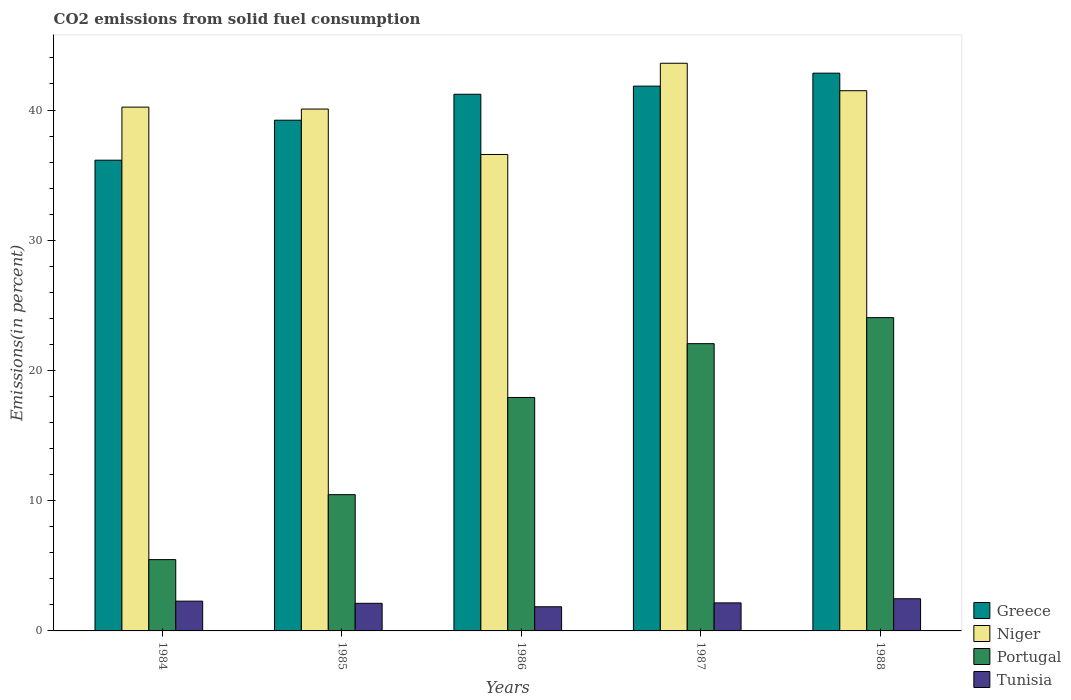Are the number of bars per tick equal to the number of legend labels?
Keep it short and to the point. Yes. Are the number of bars on each tick of the X-axis equal?
Offer a terse response. Yes. How many bars are there on the 5th tick from the left?
Provide a short and direct response. 4. How many bars are there on the 4th tick from the right?
Offer a terse response. 4. What is the total CO2 emitted in Greece in 1984?
Make the answer very short. 36.15. Across all years, what is the maximum total CO2 emitted in Greece?
Provide a succinct answer. 42.83. Across all years, what is the minimum total CO2 emitted in Portugal?
Ensure brevity in your answer.  5.48. In which year was the total CO2 emitted in Portugal maximum?
Keep it short and to the point. 1988. In which year was the total CO2 emitted in Tunisia minimum?
Provide a short and direct response. 1986. What is the total total CO2 emitted in Greece in the graph?
Offer a terse response. 201.24. What is the difference between the total CO2 emitted in Tunisia in 1984 and that in 1985?
Keep it short and to the point. 0.17. What is the difference between the total CO2 emitted in Portugal in 1988 and the total CO2 emitted in Niger in 1985?
Provide a succinct answer. -16.02. What is the average total CO2 emitted in Niger per year?
Offer a terse response. 40.39. In the year 1988, what is the difference between the total CO2 emitted in Tunisia and total CO2 emitted in Greece?
Your answer should be very brief. -40.36. In how many years, is the total CO2 emitted in Niger greater than 18 %?
Offer a terse response. 5. What is the ratio of the total CO2 emitted in Greece in 1985 to that in 1988?
Your response must be concise. 0.92. What is the difference between the highest and the second highest total CO2 emitted in Niger?
Offer a terse response. 2.11. What is the difference between the highest and the lowest total CO2 emitted in Greece?
Your answer should be very brief. 6.68. In how many years, is the total CO2 emitted in Niger greater than the average total CO2 emitted in Niger taken over all years?
Your response must be concise. 2. Is the sum of the total CO2 emitted in Niger in 1984 and 1985 greater than the maximum total CO2 emitted in Tunisia across all years?
Your answer should be very brief. Yes. Is it the case that in every year, the sum of the total CO2 emitted in Greece and total CO2 emitted in Portugal is greater than the sum of total CO2 emitted in Niger and total CO2 emitted in Tunisia?
Make the answer very short. No. What does the 4th bar from the right in 1986 represents?
Ensure brevity in your answer.  Greece. How many bars are there?
Make the answer very short. 20. How many years are there in the graph?
Offer a terse response. 5. What is the difference between two consecutive major ticks on the Y-axis?
Make the answer very short. 10. Does the graph contain grids?
Make the answer very short. No. Where does the legend appear in the graph?
Keep it short and to the point. Bottom right. How many legend labels are there?
Offer a very short reply. 4. How are the legend labels stacked?
Give a very brief answer. Vertical. What is the title of the graph?
Make the answer very short. CO2 emissions from solid fuel consumption. Does "Oman" appear as one of the legend labels in the graph?
Offer a terse response. No. What is the label or title of the Y-axis?
Give a very brief answer. Emissions(in percent). What is the Emissions(in percent) in Greece in 1984?
Make the answer very short. 36.15. What is the Emissions(in percent) in Niger in 1984?
Keep it short and to the point. 40.22. What is the Emissions(in percent) of Portugal in 1984?
Ensure brevity in your answer.  5.48. What is the Emissions(in percent) of Tunisia in 1984?
Ensure brevity in your answer.  2.29. What is the Emissions(in percent) of Greece in 1985?
Offer a very short reply. 39.22. What is the Emissions(in percent) in Niger in 1985?
Ensure brevity in your answer.  40.07. What is the Emissions(in percent) in Portugal in 1985?
Give a very brief answer. 10.46. What is the Emissions(in percent) in Tunisia in 1985?
Provide a short and direct response. 2.12. What is the Emissions(in percent) in Greece in 1986?
Your answer should be compact. 41.21. What is the Emissions(in percent) of Niger in 1986?
Provide a short and direct response. 36.59. What is the Emissions(in percent) of Portugal in 1986?
Offer a very short reply. 17.93. What is the Emissions(in percent) of Tunisia in 1986?
Ensure brevity in your answer.  1.85. What is the Emissions(in percent) of Greece in 1987?
Provide a succinct answer. 41.83. What is the Emissions(in percent) of Niger in 1987?
Make the answer very short. 43.59. What is the Emissions(in percent) of Portugal in 1987?
Your answer should be very brief. 22.06. What is the Emissions(in percent) of Tunisia in 1987?
Your answer should be compact. 2.15. What is the Emissions(in percent) of Greece in 1988?
Provide a short and direct response. 42.83. What is the Emissions(in percent) in Niger in 1988?
Your answer should be compact. 41.48. What is the Emissions(in percent) in Portugal in 1988?
Provide a succinct answer. 24.06. What is the Emissions(in percent) in Tunisia in 1988?
Provide a short and direct response. 2.47. Across all years, what is the maximum Emissions(in percent) of Greece?
Provide a succinct answer. 42.83. Across all years, what is the maximum Emissions(in percent) in Niger?
Your answer should be compact. 43.59. Across all years, what is the maximum Emissions(in percent) of Portugal?
Keep it short and to the point. 24.06. Across all years, what is the maximum Emissions(in percent) in Tunisia?
Provide a short and direct response. 2.47. Across all years, what is the minimum Emissions(in percent) of Greece?
Keep it short and to the point. 36.15. Across all years, what is the minimum Emissions(in percent) in Niger?
Make the answer very short. 36.59. Across all years, what is the minimum Emissions(in percent) in Portugal?
Keep it short and to the point. 5.48. Across all years, what is the minimum Emissions(in percent) in Tunisia?
Offer a very short reply. 1.85. What is the total Emissions(in percent) in Greece in the graph?
Provide a short and direct response. 201.24. What is the total Emissions(in percent) of Niger in the graph?
Offer a very short reply. 201.95. What is the total Emissions(in percent) in Portugal in the graph?
Keep it short and to the point. 79.98. What is the total Emissions(in percent) in Tunisia in the graph?
Keep it short and to the point. 10.88. What is the difference between the Emissions(in percent) in Greece in 1984 and that in 1985?
Offer a very short reply. -3.07. What is the difference between the Emissions(in percent) of Niger in 1984 and that in 1985?
Provide a short and direct response. 0.15. What is the difference between the Emissions(in percent) of Portugal in 1984 and that in 1985?
Provide a succinct answer. -4.99. What is the difference between the Emissions(in percent) in Tunisia in 1984 and that in 1985?
Provide a short and direct response. 0.17. What is the difference between the Emissions(in percent) of Greece in 1984 and that in 1986?
Offer a terse response. -5.06. What is the difference between the Emissions(in percent) of Niger in 1984 and that in 1986?
Your response must be concise. 3.64. What is the difference between the Emissions(in percent) in Portugal in 1984 and that in 1986?
Provide a short and direct response. -12.45. What is the difference between the Emissions(in percent) in Tunisia in 1984 and that in 1986?
Keep it short and to the point. 0.43. What is the difference between the Emissions(in percent) in Greece in 1984 and that in 1987?
Your answer should be compact. -5.69. What is the difference between the Emissions(in percent) in Niger in 1984 and that in 1987?
Offer a very short reply. -3.37. What is the difference between the Emissions(in percent) in Portugal in 1984 and that in 1987?
Offer a terse response. -16.58. What is the difference between the Emissions(in percent) in Tunisia in 1984 and that in 1987?
Make the answer very short. 0.13. What is the difference between the Emissions(in percent) in Greece in 1984 and that in 1988?
Keep it short and to the point. -6.68. What is the difference between the Emissions(in percent) of Niger in 1984 and that in 1988?
Make the answer very short. -1.26. What is the difference between the Emissions(in percent) of Portugal in 1984 and that in 1988?
Give a very brief answer. -18.58. What is the difference between the Emissions(in percent) in Tunisia in 1984 and that in 1988?
Keep it short and to the point. -0.18. What is the difference between the Emissions(in percent) of Greece in 1985 and that in 1986?
Keep it short and to the point. -1.99. What is the difference between the Emissions(in percent) in Niger in 1985 and that in 1986?
Give a very brief answer. 3.49. What is the difference between the Emissions(in percent) of Portugal in 1985 and that in 1986?
Provide a short and direct response. -7.46. What is the difference between the Emissions(in percent) in Tunisia in 1985 and that in 1986?
Provide a short and direct response. 0.27. What is the difference between the Emissions(in percent) in Greece in 1985 and that in 1987?
Give a very brief answer. -2.62. What is the difference between the Emissions(in percent) of Niger in 1985 and that in 1987?
Your answer should be very brief. -3.52. What is the difference between the Emissions(in percent) of Portugal in 1985 and that in 1987?
Your answer should be very brief. -11.6. What is the difference between the Emissions(in percent) of Tunisia in 1985 and that in 1987?
Give a very brief answer. -0.03. What is the difference between the Emissions(in percent) of Greece in 1985 and that in 1988?
Ensure brevity in your answer.  -3.61. What is the difference between the Emissions(in percent) in Niger in 1985 and that in 1988?
Ensure brevity in your answer.  -1.41. What is the difference between the Emissions(in percent) of Portugal in 1985 and that in 1988?
Provide a succinct answer. -13.59. What is the difference between the Emissions(in percent) of Tunisia in 1985 and that in 1988?
Your answer should be very brief. -0.35. What is the difference between the Emissions(in percent) in Greece in 1986 and that in 1987?
Make the answer very short. -0.62. What is the difference between the Emissions(in percent) of Niger in 1986 and that in 1987?
Provide a short and direct response. -7. What is the difference between the Emissions(in percent) of Portugal in 1986 and that in 1987?
Your answer should be compact. -4.13. What is the difference between the Emissions(in percent) in Tunisia in 1986 and that in 1987?
Give a very brief answer. -0.3. What is the difference between the Emissions(in percent) of Greece in 1986 and that in 1988?
Your answer should be very brief. -1.62. What is the difference between the Emissions(in percent) of Niger in 1986 and that in 1988?
Your answer should be very brief. -4.9. What is the difference between the Emissions(in percent) in Portugal in 1986 and that in 1988?
Your answer should be very brief. -6.13. What is the difference between the Emissions(in percent) of Tunisia in 1986 and that in 1988?
Keep it short and to the point. -0.62. What is the difference between the Emissions(in percent) in Greece in 1987 and that in 1988?
Make the answer very short. -1. What is the difference between the Emissions(in percent) in Niger in 1987 and that in 1988?
Offer a very short reply. 2.11. What is the difference between the Emissions(in percent) in Portugal in 1987 and that in 1988?
Give a very brief answer. -2. What is the difference between the Emissions(in percent) of Tunisia in 1987 and that in 1988?
Ensure brevity in your answer.  -0.32. What is the difference between the Emissions(in percent) of Greece in 1984 and the Emissions(in percent) of Niger in 1985?
Your response must be concise. -3.93. What is the difference between the Emissions(in percent) of Greece in 1984 and the Emissions(in percent) of Portugal in 1985?
Provide a short and direct response. 25.68. What is the difference between the Emissions(in percent) in Greece in 1984 and the Emissions(in percent) in Tunisia in 1985?
Make the answer very short. 34.03. What is the difference between the Emissions(in percent) of Niger in 1984 and the Emissions(in percent) of Portugal in 1985?
Give a very brief answer. 29.76. What is the difference between the Emissions(in percent) in Niger in 1984 and the Emissions(in percent) in Tunisia in 1985?
Your response must be concise. 38.1. What is the difference between the Emissions(in percent) of Portugal in 1984 and the Emissions(in percent) of Tunisia in 1985?
Make the answer very short. 3.36. What is the difference between the Emissions(in percent) of Greece in 1984 and the Emissions(in percent) of Niger in 1986?
Your response must be concise. -0.44. What is the difference between the Emissions(in percent) in Greece in 1984 and the Emissions(in percent) in Portugal in 1986?
Ensure brevity in your answer.  18.22. What is the difference between the Emissions(in percent) of Greece in 1984 and the Emissions(in percent) of Tunisia in 1986?
Your answer should be compact. 34.29. What is the difference between the Emissions(in percent) in Niger in 1984 and the Emissions(in percent) in Portugal in 1986?
Your response must be concise. 22.3. What is the difference between the Emissions(in percent) in Niger in 1984 and the Emissions(in percent) in Tunisia in 1986?
Offer a terse response. 38.37. What is the difference between the Emissions(in percent) in Portugal in 1984 and the Emissions(in percent) in Tunisia in 1986?
Make the answer very short. 3.62. What is the difference between the Emissions(in percent) in Greece in 1984 and the Emissions(in percent) in Niger in 1987?
Give a very brief answer. -7.44. What is the difference between the Emissions(in percent) in Greece in 1984 and the Emissions(in percent) in Portugal in 1987?
Keep it short and to the point. 14.09. What is the difference between the Emissions(in percent) in Greece in 1984 and the Emissions(in percent) in Tunisia in 1987?
Provide a short and direct response. 33.99. What is the difference between the Emissions(in percent) in Niger in 1984 and the Emissions(in percent) in Portugal in 1987?
Offer a very short reply. 18.16. What is the difference between the Emissions(in percent) in Niger in 1984 and the Emissions(in percent) in Tunisia in 1987?
Offer a terse response. 38.07. What is the difference between the Emissions(in percent) in Portugal in 1984 and the Emissions(in percent) in Tunisia in 1987?
Provide a short and direct response. 3.32. What is the difference between the Emissions(in percent) of Greece in 1984 and the Emissions(in percent) of Niger in 1988?
Your answer should be very brief. -5.34. What is the difference between the Emissions(in percent) of Greece in 1984 and the Emissions(in percent) of Portugal in 1988?
Ensure brevity in your answer.  12.09. What is the difference between the Emissions(in percent) in Greece in 1984 and the Emissions(in percent) in Tunisia in 1988?
Give a very brief answer. 33.67. What is the difference between the Emissions(in percent) in Niger in 1984 and the Emissions(in percent) in Portugal in 1988?
Ensure brevity in your answer.  16.17. What is the difference between the Emissions(in percent) of Niger in 1984 and the Emissions(in percent) of Tunisia in 1988?
Make the answer very short. 37.75. What is the difference between the Emissions(in percent) in Portugal in 1984 and the Emissions(in percent) in Tunisia in 1988?
Your response must be concise. 3. What is the difference between the Emissions(in percent) in Greece in 1985 and the Emissions(in percent) in Niger in 1986?
Your response must be concise. 2.63. What is the difference between the Emissions(in percent) of Greece in 1985 and the Emissions(in percent) of Portugal in 1986?
Give a very brief answer. 21.29. What is the difference between the Emissions(in percent) in Greece in 1985 and the Emissions(in percent) in Tunisia in 1986?
Make the answer very short. 37.36. What is the difference between the Emissions(in percent) in Niger in 1985 and the Emissions(in percent) in Portugal in 1986?
Ensure brevity in your answer.  22.15. What is the difference between the Emissions(in percent) in Niger in 1985 and the Emissions(in percent) in Tunisia in 1986?
Your answer should be compact. 38.22. What is the difference between the Emissions(in percent) of Portugal in 1985 and the Emissions(in percent) of Tunisia in 1986?
Make the answer very short. 8.61. What is the difference between the Emissions(in percent) in Greece in 1985 and the Emissions(in percent) in Niger in 1987?
Provide a short and direct response. -4.37. What is the difference between the Emissions(in percent) in Greece in 1985 and the Emissions(in percent) in Portugal in 1987?
Keep it short and to the point. 17.16. What is the difference between the Emissions(in percent) in Greece in 1985 and the Emissions(in percent) in Tunisia in 1987?
Give a very brief answer. 37.06. What is the difference between the Emissions(in percent) in Niger in 1985 and the Emissions(in percent) in Portugal in 1987?
Make the answer very short. 18.02. What is the difference between the Emissions(in percent) in Niger in 1985 and the Emissions(in percent) in Tunisia in 1987?
Your answer should be very brief. 37.92. What is the difference between the Emissions(in percent) of Portugal in 1985 and the Emissions(in percent) of Tunisia in 1987?
Offer a terse response. 8.31. What is the difference between the Emissions(in percent) in Greece in 1985 and the Emissions(in percent) in Niger in 1988?
Offer a very short reply. -2.26. What is the difference between the Emissions(in percent) in Greece in 1985 and the Emissions(in percent) in Portugal in 1988?
Provide a short and direct response. 15.16. What is the difference between the Emissions(in percent) in Greece in 1985 and the Emissions(in percent) in Tunisia in 1988?
Your response must be concise. 36.75. What is the difference between the Emissions(in percent) in Niger in 1985 and the Emissions(in percent) in Portugal in 1988?
Your answer should be very brief. 16.02. What is the difference between the Emissions(in percent) in Niger in 1985 and the Emissions(in percent) in Tunisia in 1988?
Keep it short and to the point. 37.6. What is the difference between the Emissions(in percent) in Portugal in 1985 and the Emissions(in percent) in Tunisia in 1988?
Provide a short and direct response. 7.99. What is the difference between the Emissions(in percent) in Greece in 1986 and the Emissions(in percent) in Niger in 1987?
Your response must be concise. -2.38. What is the difference between the Emissions(in percent) in Greece in 1986 and the Emissions(in percent) in Portugal in 1987?
Ensure brevity in your answer.  19.15. What is the difference between the Emissions(in percent) of Greece in 1986 and the Emissions(in percent) of Tunisia in 1987?
Make the answer very short. 39.06. What is the difference between the Emissions(in percent) in Niger in 1986 and the Emissions(in percent) in Portugal in 1987?
Your answer should be very brief. 14.53. What is the difference between the Emissions(in percent) in Niger in 1986 and the Emissions(in percent) in Tunisia in 1987?
Keep it short and to the point. 34.43. What is the difference between the Emissions(in percent) of Portugal in 1986 and the Emissions(in percent) of Tunisia in 1987?
Your answer should be compact. 15.77. What is the difference between the Emissions(in percent) in Greece in 1986 and the Emissions(in percent) in Niger in 1988?
Provide a succinct answer. -0.27. What is the difference between the Emissions(in percent) of Greece in 1986 and the Emissions(in percent) of Portugal in 1988?
Offer a very short reply. 17.15. What is the difference between the Emissions(in percent) in Greece in 1986 and the Emissions(in percent) in Tunisia in 1988?
Give a very brief answer. 38.74. What is the difference between the Emissions(in percent) in Niger in 1986 and the Emissions(in percent) in Portugal in 1988?
Your response must be concise. 12.53. What is the difference between the Emissions(in percent) of Niger in 1986 and the Emissions(in percent) of Tunisia in 1988?
Make the answer very short. 34.11. What is the difference between the Emissions(in percent) of Portugal in 1986 and the Emissions(in percent) of Tunisia in 1988?
Offer a terse response. 15.45. What is the difference between the Emissions(in percent) in Greece in 1987 and the Emissions(in percent) in Niger in 1988?
Provide a short and direct response. 0.35. What is the difference between the Emissions(in percent) of Greece in 1987 and the Emissions(in percent) of Portugal in 1988?
Provide a short and direct response. 17.78. What is the difference between the Emissions(in percent) of Greece in 1987 and the Emissions(in percent) of Tunisia in 1988?
Provide a succinct answer. 39.36. What is the difference between the Emissions(in percent) in Niger in 1987 and the Emissions(in percent) in Portugal in 1988?
Ensure brevity in your answer.  19.53. What is the difference between the Emissions(in percent) of Niger in 1987 and the Emissions(in percent) of Tunisia in 1988?
Provide a short and direct response. 41.12. What is the difference between the Emissions(in percent) in Portugal in 1987 and the Emissions(in percent) in Tunisia in 1988?
Provide a short and direct response. 19.59. What is the average Emissions(in percent) of Greece per year?
Offer a terse response. 40.25. What is the average Emissions(in percent) of Niger per year?
Your response must be concise. 40.39. What is the average Emissions(in percent) of Portugal per year?
Give a very brief answer. 16. What is the average Emissions(in percent) in Tunisia per year?
Your answer should be compact. 2.18. In the year 1984, what is the difference between the Emissions(in percent) in Greece and Emissions(in percent) in Niger?
Keep it short and to the point. -4.08. In the year 1984, what is the difference between the Emissions(in percent) of Greece and Emissions(in percent) of Portugal?
Offer a very short reply. 30.67. In the year 1984, what is the difference between the Emissions(in percent) of Greece and Emissions(in percent) of Tunisia?
Make the answer very short. 33.86. In the year 1984, what is the difference between the Emissions(in percent) in Niger and Emissions(in percent) in Portugal?
Your answer should be compact. 34.75. In the year 1984, what is the difference between the Emissions(in percent) of Niger and Emissions(in percent) of Tunisia?
Provide a short and direct response. 37.94. In the year 1984, what is the difference between the Emissions(in percent) in Portugal and Emissions(in percent) in Tunisia?
Provide a short and direct response. 3.19. In the year 1985, what is the difference between the Emissions(in percent) in Greece and Emissions(in percent) in Niger?
Your answer should be compact. -0.86. In the year 1985, what is the difference between the Emissions(in percent) in Greece and Emissions(in percent) in Portugal?
Offer a very short reply. 28.75. In the year 1985, what is the difference between the Emissions(in percent) of Greece and Emissions(in percent) of Tunisia?
Offer a very short reply. 37.1. In the year 1985, what is the difference between the Emissions(in percent) of Niger and Emissions(in percent) of Portugal?
Your answer should be compact. 29.61. In the year 1985, what is the difference between the Emissions(in percent) in Niger and Emissions(in percent) in Tunisia?
Your response must be concise. 37.95. In the year 1985, what is the difference between the Emissions(in percent) of Portugal and Emissions(in percent) of Tunisia?
Provide a short and direct response. 8.34. In the year 1986, what is the difference between the Emissions(in percent) of Greece and Emissions(in percent) of Niger?
Offer a very short reply. 4.62. In the year 1986, what is the difference between the Emissions(in percent) in Greece and Emissions(in percent) in Portugal?
Offer a very short reply. 23.28. In the year 1986, what is the difference between the Emissions(in percent) of Greece and Emissions(in percent) of Tunisia?
Your answer should be compact. 39.36. In the year 1986, what is the difference between the Emissions(in percent) in Niger and Emissions(in percent) in Portugal?
Make the answer very short. 18.66. In the year 1986, what is the difference between the Emissions(in percent) in Niger and Emissions(in percent) in Tunisia?
Give a very brief answer. 34.73. In the year 1986, what is the difference between the Emissions(in percent) in Portugal and Emissions(in percent) in Tunisia?
Offer a terse response. 16.07. In the year 1987, what is the difference between the Emissions(in percent) in Greece and Emissions(in percent) in Niger?
Provide a short and direct response. -1.76. In the year 1987, what is the difference between the Emissions(in percent) in Greece and Emissions(in percent) in Portugal?
Give a very brief answer. 19.78. In the year 1987, what is the difference between the Emissions(in percent) of Greece and Emissions(in percent) of Tunisia?
Your response must be concise. 39.68. In the year 1987, what is the difference between the Emissions(in percent) of Niger and Emissions(in percent) of Portugal?
Ensure brevity in your answer.  21.53. In the year 1987, what is the difference between the Emissions(in percent) in Niger and Emissions(in percent) in Tunisia?
Your answer should be compact. 41.44. In the year 1987, what is the difference between the Emissions(in percent) in Portugal and Emissions(in percent) in Tunisia?
Provide a succinct answer. 19.9. In the year 1988, what is the difference between the Emissions(in percent) in Greece and Emissions(in percent) in Niger?
Give a very brief answer. 1.35. In the year 1988, what is the difference between the Emissions(in percent) of Greece and Emissions(in percent) of Portugal?
Make the answer very short. 18.77. In the year 1988, what is the difference between the Emissions(in percent) in Greece and Emissions(in percent) in Tunisia?
Give a very brief answer. 40.36. In the year 1988, what is the difference between the Emissions(in percent) of Niger and Emissions(in percent) of Portugal?
Offer a very short reply. 17.43. In the year 1988, what is the difference between the Emissions(in percent) of Niger and Emissions(in percent) of Tunisia?
Provide a short and direct response. 39.01. In the year 1988, what is the difference between the Emissions(in percent) of Portugal and Emissions(in percent) of Tunisia?
Ensure brevity in your answer.  21.58. What is the ratio of the Emissions(in percent) in Greece in 1984 to that in 1985?
Your response must be concise. 0.92. What is the ratio of the Emissions(in percent) in Niger in 1984 to that in 1985?
Provide a succinct answer. 1. What is the ratio of the Emissions(in percent) in Portugal in 1984 to that in 1985?
Offer a very short reply. 0.52. What is the ratio of the Emissions(in percent) of Tunisia in 1984 to that in 1985?
Offer a terse response. 1.08. What is the ratio of the Emissions(in percent) in Greece in 1984 to that in 1986?
Ensure brevity in your answer.  0.88. What is the ratio of the Emissions(in percent) of Niger in 1984 to that in 1986?
Ensure brevity in your answer.  1.1. What is the ratio of the Emissions(in percent) in Portugal in 1984 to that in 1986?
Offer a very short reply. 0.31. What is the ratio of the Emissions(in percent) in Tunisia in 1984 to that in 1986?
Give a very brief answer. 1.23. What is the ratio of the Emissions(in percent) in Greece in 1984 to that in 1987?
Your answer should be compact. 0.86. What is the ratio of the Emissions(in percent) in Niger in 1984 to that in 1987?
Your answer should be compact. 0.92. What is the ratio of the Emissions(in percent) in Portugal in 1984 to that in 1987?
Offer a terse response. 0.25. What is the ratio of the Emissions(in percent) of Tunisia in 1984 to that in 1987?
Keep it short and to the point. 1.06. What is the ratio of the Emissions(in percent) in Greece in 1984 to that in 1988?
Your answer should be very brief. 0.84. What is the ratio of the Emissions(in percent) of Niger in 1984 to that in 1988?
Make the answer very short. 0.97. What is the ratio of the Emissions(in percent) in Portugal in 1984 to that in 1988?
Your response must be concise. 0.23. What is the ratio of the Emissions(in percent) of Tunisia in 1984 to that in 1988?
Your answer should be compact. 0.93. What is the ratio of the Emissions(in percent) of Greece in 1985 to that in 1986?
Your response must be concise. 0.95. What is the ratio of the Emissions(in percent) of Niger in 1985 to that in 1986?
Your response must be concise. 1.1. What is the ratio of the Emissions(in percent) of Portugal in 1985 to that in 1986?
Provide a short and direct response. 0.58. What is the ratio of the Emissions(in percent) in Tunisia in 1985 to that in 1986?
Keep it short and to the point. 1.14. What is the ratio of the Emissions(in percent) in Greece in 1985 to that in 1987?
Your answer should be compact. 0.94. What is the ratio of the Emissions(in percent) in Niger in 1985 to that in 1987?
Your answer should be compact. 0.92. What is the ratio of the Emissions(in percent) in Portugal in 1985 to that in 1987?
Give a very brief answer. 0.47. What is the ratio of the Emissions(in percent) of Greece in 1985 to that in 1988?
Provide a succinct answer. 0.92. What is the ratio of the Emissions(in percent) of Niger in 1985 to that in 1988?
Make the answer very short. 0.97. What is the ratio of the Emissions(in percent) in Portugal in 1985 to that in 1988?
Make the answer very short. 0.43. What is the ratio of the Emissions(in percent) in Tunisia in 1985 to that in 1988?
Offer a very short reply. 0.86. What is the ratio of the Emissions(in percent) in Greece in 1986 to that in 1987?
Provide a short and direct response. 0.99. What is the ratio of the Emissions(in percent) of Niger in 1986 to that in 1987?
Make the answer very short. 0.84. What is the ratio of the Emissions(in percent) in Portugal in 1986 to that in 1987?
Your answer should be very brief. 0.81. What is the ratio of the Emissions(in percent) of Tunisia in 1986 to that in 1987?
Your response must be concise. 0.86. What is the ratio of the Emissions(in percent) in Greece in 1986 to that in 1988?
Your answer should be very brief. 0.96. What is the ratio of the Emissions(in percent) of Niger in 1986 to that in 1988?
Your response must be concise. 0.88. What is the ratio of the Emissions(in percent) in Portugal in 1986 to that in 1988?
Offer a very short reply. 0.75. What is the ratio of the Emissions(in percent) in Tunisia in 1986 to that in 1988?
Offer a very short reply. 0.75. What is the ratio of the Emissions(in percent) of Greece in 1987 to that in 1988?
Give a very brief answer. 0.98. What is the ratio of the Emissions(in percent) in Niger in 1987 to that in 1988?
Provide a succinct answer. 1.05. What is the ratio of the Emissions(in percent) of Portugal in 1987 to that in 1988?
Give a very brief answer. 0.92. What is the ratio of the Emissions(in percent) of Tunisia in 1987 to that in 1988?
Keep it short and to the point. 0.87. What is the difference between the highest and the second highest Emissions(in percent) in Niger?
Your response must be concise. 2.11. What is the difference between the highest and the second highest Emissions(in percent) in Portugal?
Your response must be concise. 2. What is the difference between the highest and the second highest Emissions(in percent) of Tunisia?
Offer a terse response. 0.18. What is the difference between the highest and the lowest Emissions(in percent) of Greece?
Give a very brief answer. 6.68. What is the difference between the highest and the lowest Emissions(in percent) in Niger?
Make the answer very short. 7. What is the difference between the highest and the lowest Emissions(in percent) of Portugal?
Provide a short and direct response. 18.58. What is the difference between the highest and the lowest Emissions(in percent) in Tunisia?
Make the answer very short. 0.62. 